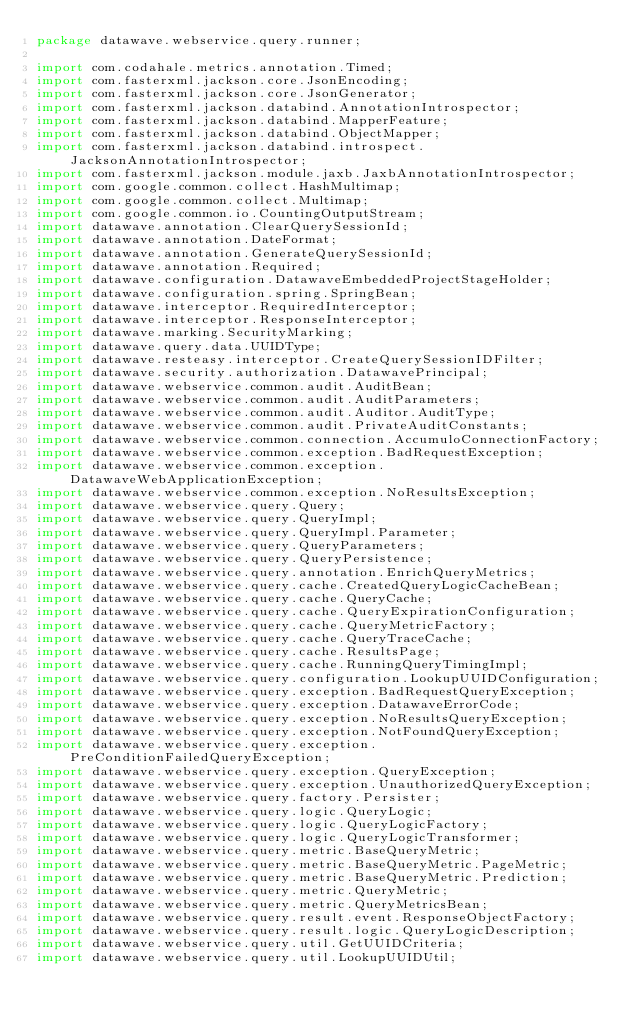Convert code to text. <code><loc_0><loc_0><loc_500><loc_500><_Java_>package datawave.webservice.query.runner;

import com.codahale.metrics.annotation.Timed;
import com.fasterxml.jackson.core.JsonEncoding;
import com.fasterxml.jackson.core.JsonGenerator;
import com.fasterxml.jackson.databind.AnnotationIntrospector;
import com.fasterxml.jackson.databind.MapperFeature;
import com.fasterxml.jackson.databind.ObjectMapper;
import com.fasterxml.jackson.databind.introspect.JacksonAnnotationIntrospector;
import com.fasterxml.jackson.module.jaxb.JaxbAnnotationIntrospector;
import com.google.common.collect.HashMultimap;
import com.google.common.collect.Multimap;
import com.google.common.io.CountingOutputStream;
import datawave.annotation.ClearQuerySessionId;
import datawave.annotation.DateFormat;
import datawave.annotation.GenerateQuerySessionId;
import datawave.annotation.Required;
import datawave.configuration.DatawaveEmbeddedProjectStageHolder;
import datawave.configuration.spring.SpringBean;
import datawave.interceptor.RequiredInterceptor;
import datawave.interceptor.ResponseInterceptor;
import datawave.marking.SecurityMarking;
import datawave.query.data.UUIDType;
import datawave.resteasy.interceptor.CreateQuerySessionIDFilter;
import datawave.security.authorization.DatawavePrincipal;
import datawave.webservice.common.audit.AuditBean;
import datawave.webservice.common.audit.AuditParameters;
import datawave.webservice.common.audit.Auditor.AuditType;
import datawave.webservice.common.audit.PrivateAuditConstants;
import datawave.webservice.common.connection.AccumuloConnectionFactory;
import datawave.webservice.common.exception.BadRequestException;
import datawave.webservice.common.exception.DatawaveWebApplicationException;
import datawave.webservice.common.exception.NoResultsException;
import datawave.webservice.query.Query;
import datawave.webservice.query.QueryImpl;
import datawave.webservice.query.QueryImpl.Parameter;
import datawave.webservice.query.QueryParameters;
import datawave.webservice.query.QueryPersistence;
import datawave.webservice.query.annotation.EnrichQueryMetrics;
import datawave.webservice.query.cache.CreatedQueryLogicCacheBean;
import datawave.webservice.query.cache.QueryCache;
import datawave.webservice.query.cache.QueryExpirationConfiguration;
import datawave.webservice.query.cache.QueryMetricFactory;
import datawave.webservice.query.cache.QueryTraceCache;
import datawave.webservice.query.cache.ResultsPage;
import datawave.webservice.query.cache.RunningQueryTimingImpl;
import datawave.webservice.query.configuration.LookupUUIDConfiguration;
import datawave.webservice.query.exception.BadRequestQueryException;
import datawave.webservice.query.exception.DatawaveErrorCode;
import datawave.webservice.query.exception.NoResultsQueryException;
import datawave.webservice.query.exception.NotFoundQueryException;
import datawave.webservice.query.exception.PreConditionFailedQueryException;
import datawave.webservice.query.exception.QueryException;
import datawave.webservice.query.exception.UnauthorizedQueryException;
import datawave.webservice.query.factory.Persister;
import datawave.webservice.query.logic.QueryLogic;
import datawave.webservice.query.logic.QueryLogicFactory;
import datawave.webservice.query.logic.QueryLogicTransformer;
import datawave.webservice.query.metric.BaseQueryMetric;
import datawave.webservice.query.metric.BaseQueryMetric.PageMetric;
import datawave.webservice.query.metric.BaseQueryMetric.Prediction;
import datawave.webservice.query.metric.QueryMetric;
import datawave.webservice.query.metric.QueryMetricsBean;
import datawave.webservice.query.result.event.ResponseObjectFactory;
import datawave.webservice.query.result.logic.QueryLogicDescription;
import datawave.webservice.query.util.GetUUIDCriteria;
import datawave.webservice.query.util.LookupUUIDUtil;</code> 